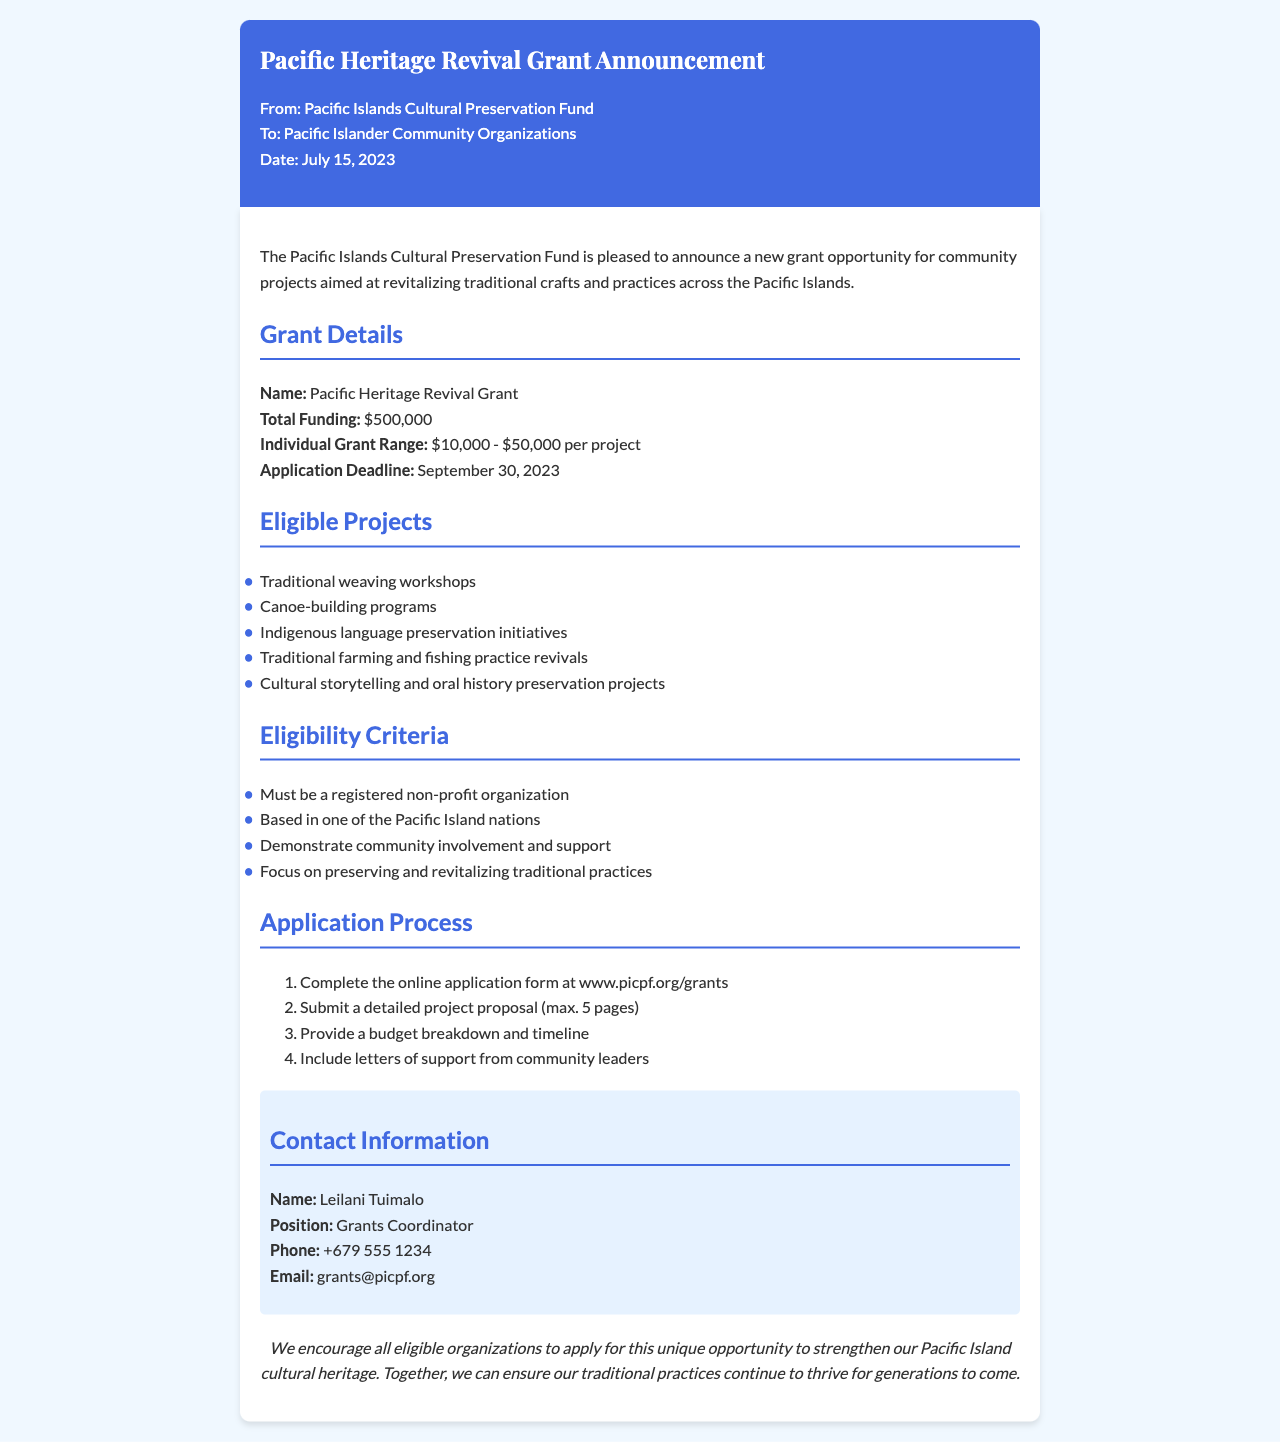What is the name of the grant? The name of the grant is explicitly stated in the document's details section.
Answer: Pacific Heritage Revival Grant What is the total funding amount? The total funding amount is mentioned directly under the grant details.
Answer: $500,000 What is the individual grant range? The individual grant range is specified in the grant details section of the document.
Answer: $10,000 - $50,000 per project When is the application deadline? The application deadline is clearly stated in the document under grant details.
Answer: September 30, 2023 What types of projects are eligible? The eligible projects are listed in a bulleted format in the document.
Answer: Traditional weaving workshops, Canoe-building programs, Indigenous language preservation initiatives, Traditional farming and fishing practice revivals, Cultural storytelling and oral history preservation projects What is one of the eligibility criteria? The eligibility criteria are outlined in a bulleted list in the document.
Answer: Must be a registered non-profit organization Who is the grants coordinator? The contact information section includes the name of the grants coordinator.
Answer: Leilani Tuimalo What should be included in the project proposal? The application process outlines specific requirements for the project proposal.
Answer: A detailed project proposal (max. 5 pages) How can organizations apply? The application process describes how eligible organizations can apply for the grant.
Answer: Complete the online application form at www.picpf.org/grants 